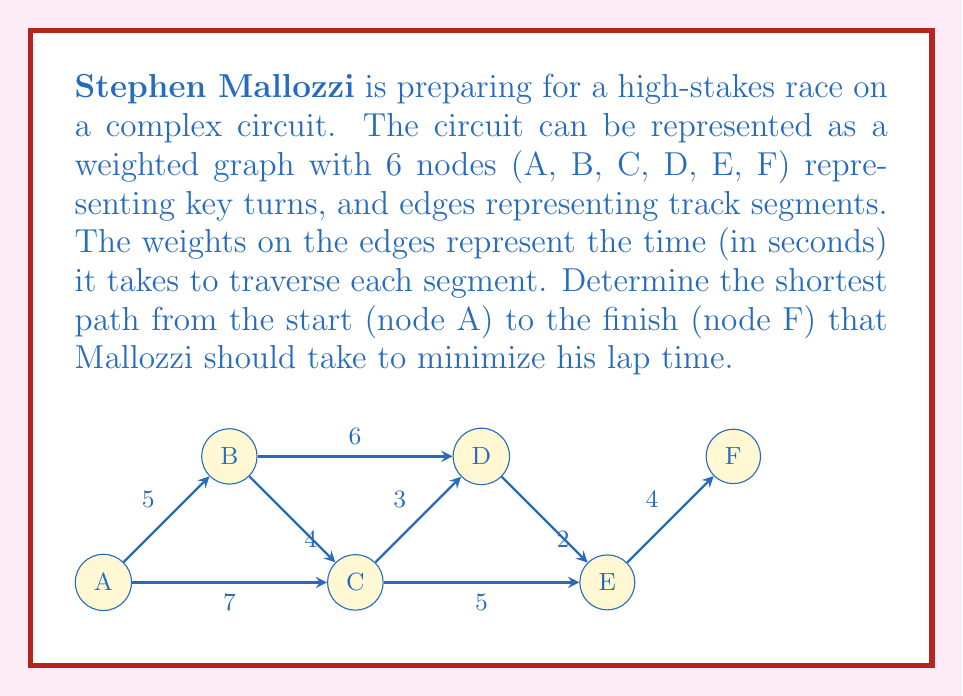Help me with this question. To solve this problem, we'll use Dijkstra's algorithm, which is optimal for finding the shortest path in a weighted graph.

Step 1: Initialize distances
Set distance to A as 0 and all other nodes as infinity.
$d(A) = 0$, $d(B) = d(C) = d(D) = d(E) = d(F) = \infty$

Step 2: Visit node A
Update distances:
$d(B) = 5$
$d(C) = 7$

Step 3: Visit node B (closest unvisited node)
Update distances:
$d(C) = \min(7, 5+4) = 7$
$d(D) = 5+6 = 11$

Step 4: Visit node C
Update distances:
$d(D) = \min(11, 7+3) = 10$
$d(E) = 7+5 = 12$

Step 5: Visit node D
Update distances:
$d(E) = \min(12, 10+2) = 12$
$d(F) = 10+4 = 14$

Step 6: Visit node E
No updates needed

Step 7: Visit node F
Algorithm complete

The shortest path is A -> B -> C -> D -> F with a total distance of 14 seconds.
Answer: A -> B -> C -> D -> F, 14 seconds 